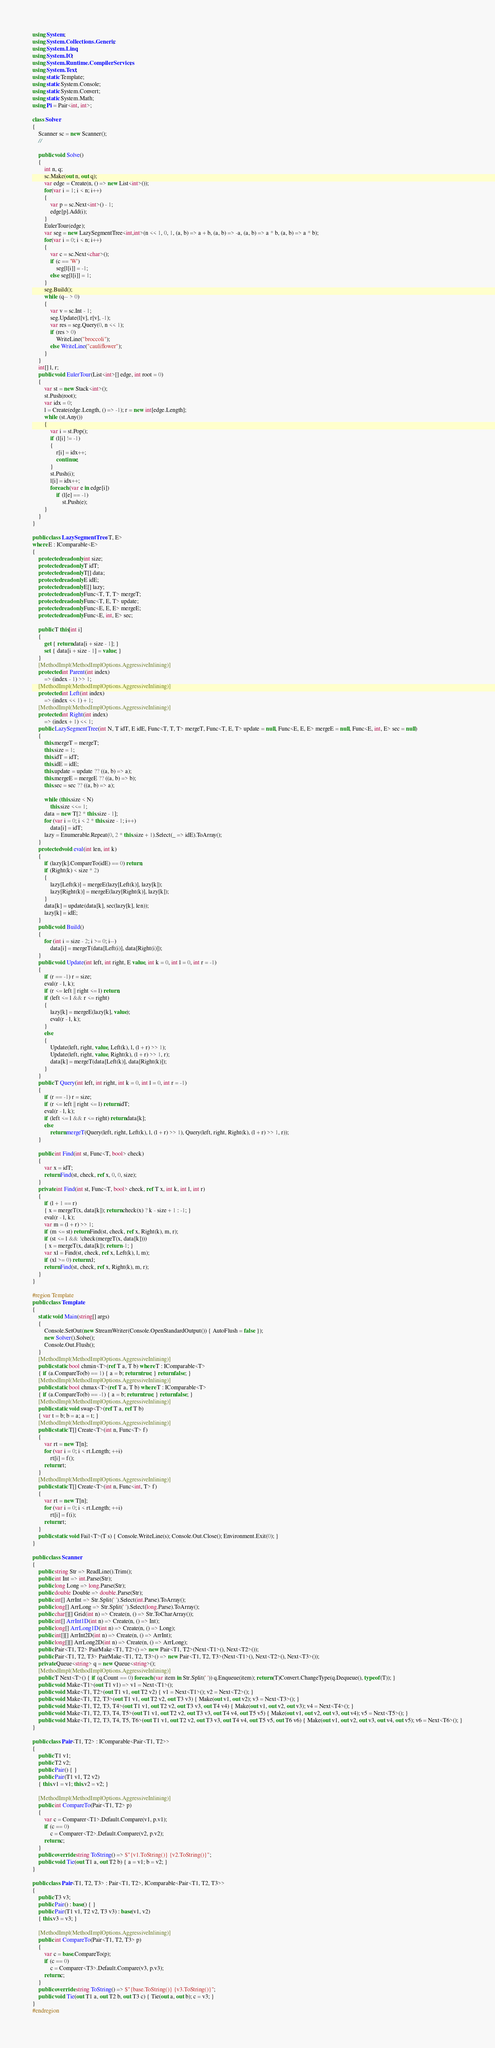Convert code to text. <code><loc_0><loc_0><loc_500><loc_500><_C#_>using System;
using System.Collections.Generic;
using System.Linq;
using System.IO;
using System.Runtime.CompilerServices;
using System.Text;
using static Template;
using static System.Console;
using static System.Convert;
using static System.Math;
using Pi = Pair<int, int>;

class Solver
{
    Scanner sc = new Scanner();
    //

    public void Solve()
    {
        int n, q;
        sc.Make(out n, out q);
        var edge = Create(n, () => new List<int>());
        for(var i = 1; i < n; i++)
        {
            var p = sc.Next<int>() - 1;
            edge[p].Add(i);
        }
        EulerTour(edge);
        var seg = new LazySegmentTree<int,int>(n << 1, 0, 1, (a, b) => a + b, (a, b) => -a, (a, b) => a * b, (a, b) => a * b);
        for(var i = 0; i < n; i++)
        {
            var c = sc.Next<char>();
            if (c == 'W')
                seg[l[i]] = -1;
            else seg[l[i]] = 1;
        }
        seg.Build();
        while (q-- > 0)
        {
            var v = sc.Int - 1;
            seg.Update(l[v], r[v], -1);
            var res = seg.Query(0, n << 1);
            if (res > 0)
                WriteLine("broccoli");
            else WriteLine("cauliflower");
        }
    }
    int[] l, r;
    public void EulerTour(List<int>[] edge, int root = 0)
    {
        var st = new Stack<int>();
        st.Push(root);
        var idx = 0;
        l = Create(edge.Length, () => -1); r = new int[edge.Length];
        while (st.Any())
        {
            var i = st.Pop();
            if (l[i] != -1)
            {
                r[i] = idx++;
                continue;
            }
            st.Push(i);
            l[i] = idx++;
            foreach (var e in edge[i])
                if (l[e] == -1)
                    st.Push(e);
        }
    }
}

public class LazySegmentTree<T, E>
where E : IComparable<E>
{
    protected readonly int size;
    protected readonly T idT;
    protected readonly T[] data;
    protected readonly E idE;
    protected readonly E[] lazy;
    protected readonly Func<T, T, T> mergeT;
    protected readonly Func<T, E, T> update;
    protected readonly Func<E, E, E> mergeE;
    protected readonly Func<E, int, E> sec;

    public T this[int i]
    {
        get { return data[i + size - 1]; }
        set { data[i + size - 1] = value; }
    }
    [MethodImpl(MethodImplOptions.AggressiveInlining)]
    protected int Parent(int index)
        => (index - 1) >> 1;
    [MethodImpl(MethodImplOptions.AggressiveInlining)]
    protected int Left(int index)
        => (index << 1) + 1;
    [MethodImpl(MethodImplOptions.AggressiveInlining)]
    protected int Right(int index)
        => (index + 1) << 1;
    public LazySegmentTree(int N, T idT, E idE, Func<T, T, T> mergeT, Func<T, E, T> update = null, Func<E, E, E> mergeE = null, Func<E, int, E> sec = null)
    {
        this.mergeT = mergeT;
        this.size = 1;
        this.idT = idT;
        this.idE = idE;
        this.update = update ?? ((a, b) => a);
        this.mergeE = mergeE ?? ((a, b) => b);
        this.sec = sec ?? ((a, b) => a);

        while (this.size < N)
            this.size <<= 1;
        data = new T[2 * this.size - 1];
        for (var i = 0; i < 2 * this.size - 1; i++)
            data[i] = idT;
        lazy = Enumerable.Repeat(0, 2 * this.size + 1).Select(_ => idE).ToArray();
    }
    protected void eval(int len, int k)
    {
        if (lazy[k].CompareTo(idE) == 0) return;
        if (Right(k) < size * 2)
        {
            lazy[Left(k)] = mergeE(lazy[Left(k)], lazy[k]);
            lazy[Right(k)] = mergeE(lazy[Right(k)], lazy[k]);
        }
        data[k] = update(data[k], sec(lazy[k], len));
        lazy[k] = idE;
    }
    public void Build()
    {
        for (int i = size - 2; i >= 0; i--)
            data[i] = mergeT(data[Left(i)], data[Right(i)]);
    }
    public void Update(int left, int right, E value, int k = 0, int l = 0, int r = -1)
    {
        if (r == -1) r = size;
        eval(r - l, k);
        if (r <= left || right <= l) return;
        if (left <= l && r <= right)
        {
            lazy[k] = mergeE(lazy[k], value);
            eval(r - l, k);
        }
        else
        {
            Update(left, right, value, Left(k), l, (l + r) >> 1);
            Update(left, right, value, Right(k), (l + r) >> 1, r);
            data[k] = mergeT(data[Left(k)], data[Right(k)]);
        }
    }
    public T Query(int left, int right, int k = 0, int l = 0, int r = -1)
    {
        if (r == -1) r = size;
        if (r <= left || right <= l) return idT;
        eval(r - l, k);
        if (left <= l && r <= right) return data[k];
        else
            return mergeT(Query(left, right, Left(k), l, (l + r) >> 1), Query(left, right, Right(k), (l + r) >> 1, r));
    }

    public int Find(int st, Func<T, bool> check)
    {
        var x = idT;
        return Find(st, check, ref x, 0, 0, size);
    }
    private int Find(int st, Func<T, bool> check, ref T x, int k, int l, int r)
    {
        if (l + 1 == r)
        { x = mergeT(x, data[k]); return check(x) ? k - size + 1 : -1; }
        eval(r - l, k);
        var m = (l + r) >> 1;
        if (m <= st) return Find(st, check, ref x, Right(k), m, r);
        if (st <= l && !check(mergeT(x, data[k])))
        { x = mergeT(x, data[k]); return -1; }
        var xl = Find(st, check, ref x, Left(k), l, m);
        if (xl >= 0) return xl;
        return Find(st, check, ref x, Right(k), m, r);
    }
}

#region Template
public class Template
{
    static void Main(string[] args)
    {
        Console.SetOut(new StreamWriter(Console.OpenStandardOutput()) { AutoFlush = false });
        new Solver().Solve();
        Console.Out.Flush();
    }
    [MethodImpl(MethodImplOptions.AggressiveInlining)]
    public static bool chmin<T>(ref T a, T b) where T : IComparable<T>
    { if (a.CompareTo(b) == 1) { a = b; return true; } return false; }
    [MethodImpl(MethodImplOptions.AggressiveInlining)]
    public static bool chmax<T>(ref T a, T b) where T : IComparable<T>
    { if (a.CompareTo(b) == -1) { a = b; return true; } return false; }
    [MethodImpl(MethodImplOptions.AggressiveInlining)]
    public static void swap<T>(ref T a, ref T b)
    { var t = b; b = a; a = t; }
    [MethodImpl(MethodImplOptions.AggressiveInlining)]
    public static T[] Create<T>(int n, Func<T> f)
    {
        var rt = new T[n];
        for (var i = 0; i < rt.Length; ++i)
            rt[i] = f();
        return rt;
    }
    [MethodImpl(MethodImplOptions.AggressiveInlining)]
    public static T[] Create<T>(int n, Func<int, T> f)
    {
        var rt = new T[n];
        for (var i = 0; i < rt.Length; ++i)
            rt[i] = f(i);
        return rt;
    }
    public static void Fail<T>(T s) { Console.WriteLine(s); Console.Out.Close(); Environment.Exit(0); }
}

public class Scanner
{
    public string Str => ReadLine().Trim();
    public int Int => int.Parse(Str);
    public long Long => long.Parse(Str);
    public double Double => double.Parse(Str);
    public int[] ArrInt => Str.Split(' ').Select(int.Parse).ToArray();
    public long[] ArrLong => Str.Split(' ').Select(long.Parse).ToArray();
    public char[][] Grid(int n) => Create(n, () => Str.ToCharArray());
    public int[] ArrInt1D(int n) => Create(n, () => Int);
    public long[] ArrLong1D(int n) => Create(n, () => Long);
    public int[][] ArrInt2D(int n) => Create(n, () => ArrInt);
    public long[][] ArrLong2D(int n) => Create(n, () => ArrLong);
    public Pair<T1, T2> PairMake<T1, T2>() => new Pair<T1, T2>(Next<T1>(), Next<T2>());
    public Pair<T1, T2, T3> PairMake<T1, T2, T3>() => new Pair<T1, T2, T3>(Next<T1>(), Next<T2>(), Next<T3>());
    private Queue<string> q = new Queue<string>();
    [MethodImpl(MethodImplOptions.AggressiveInlining)]
    public T Next<T>() { if (q.Count == 0) foreach (var item in Str.Split(' ')) q.Enqueue(item); return (T)Convert.ChangeType(q.Dequeue(), typeof(T)); }
    public void Make<T1>(out T1 v1) => v1 = Next<T1>();
    public void Make<T1, T2>(out T1 v1, out T2 v2) { v1 = Next<T1>(); v2 = Next<T2>(); }
    public void Make<T1, T2, T3>(out T1 v1, out T2 v2, out T3 v3) { Make(out v1, out v2); v3 = Next<T3>(); }
    public void Make<T1, T2, T3, T4>(out T1 v1, out T2 v2, out T3 v3, out T4 v4) { Make(out v1, out v2, out v3); v4 = Next<T4>(); }
    public void Make<T1, T2, T3, T4, T5>(out T1 v1, out T2 v2, out T3 v3, out T4 v4, out T5 v5) { Make(out v1, out v2, out v3, out v4); v5 = Next<T5>(); }
    public void Make<T1, T2, T3, T4, T5, T6>(out T1 v1, out T2 v2, out T3 v3, out T4 v4, out T5 v5, out T6 v6) { Make(out v1, out v2, out v3, out v4, out v5); v6 = Next<T6>(); }
}

public class Pair<T1, T2> : IComparable<Pair<T1, T2>>
{
    public T1 v1;
    public T2 v2;
    public Pair() { }
    public Pair(T1 v1, T2 v2)
    { this.v1 = v1; this.v2 = v2; }

    [MethodImpl(MethodImplOptions.AggressiveInlining)]
    public int CompareTo(Pair<T1, T2> p)
    {
        var c = Comparer<T1>.Default.Compare(v1, p.v1);
        if (c == 0)
            c = Comparer<T2>.Default.Compare(v2, p.v2);
        return c;
    }
    public override string ToString() => $"{v1.ToString()} {v2.ToString()}";
    public void Tie(out T1 a, out T2 b) { a = v1; b = v2; }
}

public class Pair<T1, T2, T3> : Pair<T1, T2>, IComparable<Pair<T1, T2, T3>>
{
    public T3 v3;
    public Pair() : base() { }
    public Pair(T1 v1, T2 v2, T3 v3) : base(v1, v2)
    { this.v3 = v3; }

    [MethodImpl(MethodImplOptions.AggressiveInlining)]
    public int CompareTo(Pair<T1, T2, T3> p)
    {
        var c = base.CompareTo(p);
        if (c == 0)
            c = Comparer<T3>.Default.Compare(v3, p.v3);
        return c;
    }
    public override string ToString() => $"{base.ToString()} {v3.ToString()}";
    public void Tie(out T1 a, out T2 b, out T3 c) { Tie(out a, out b); c = v3; }
}
#endregion

</code> 